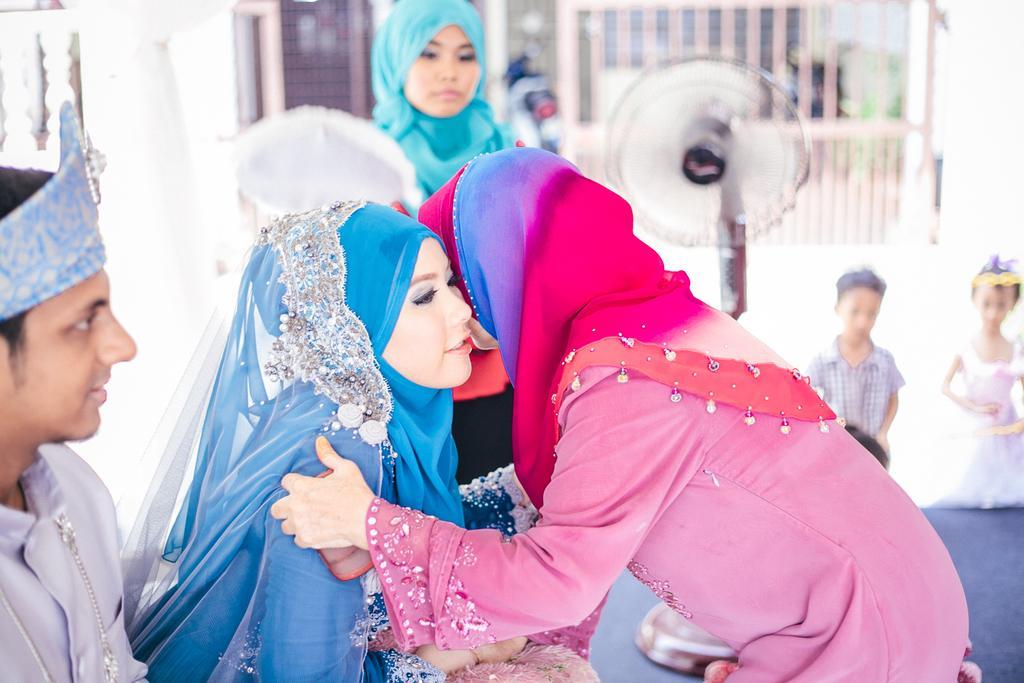Can you describe this image briefly? In this image we can see two ladies, i think they may be greeting to each other. In the background of the image we can see a girl, two kids and a fan which are in a blur. 